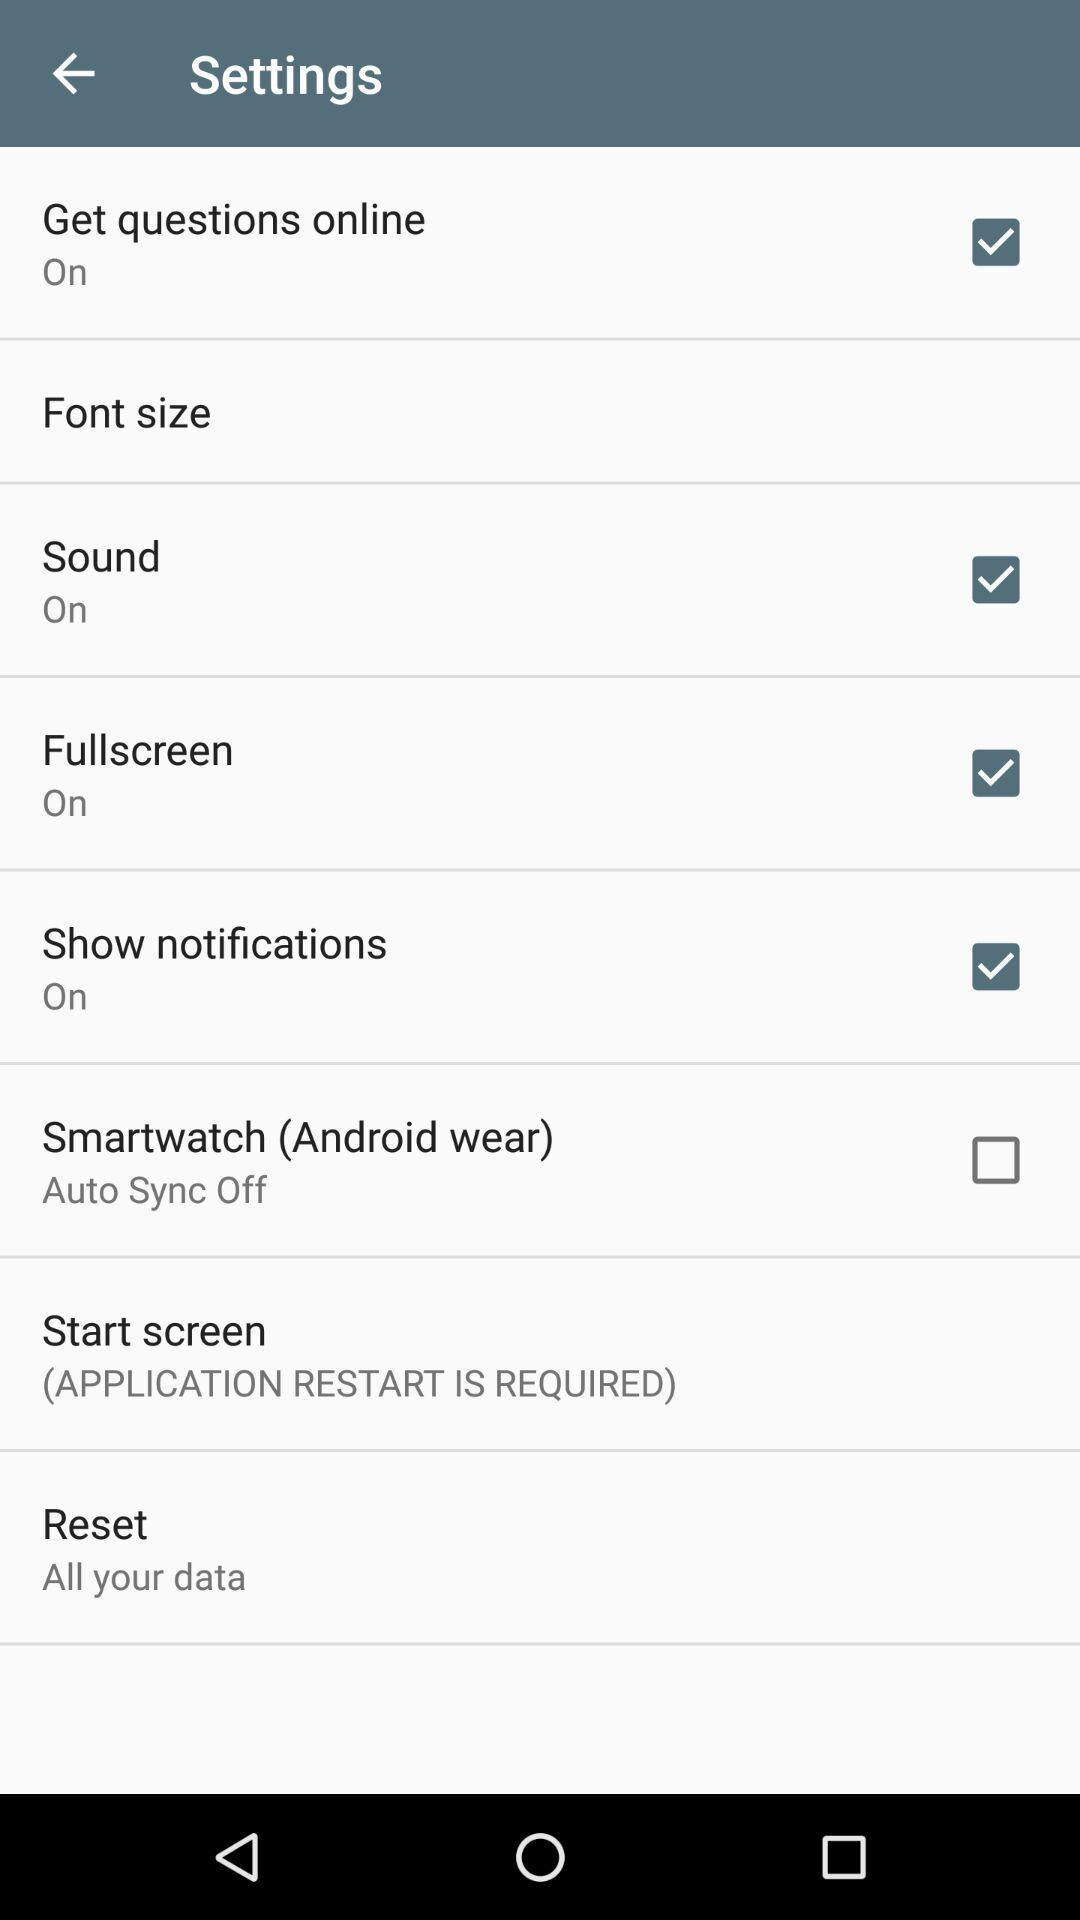For which setting is an application restart required? An application restart is required for the "Start screen" setting. 